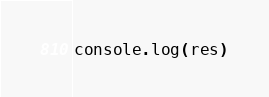<code> <loc_0><loc_0><loc_500><loc_500><_JavaScript_>console.log(res)</code> 